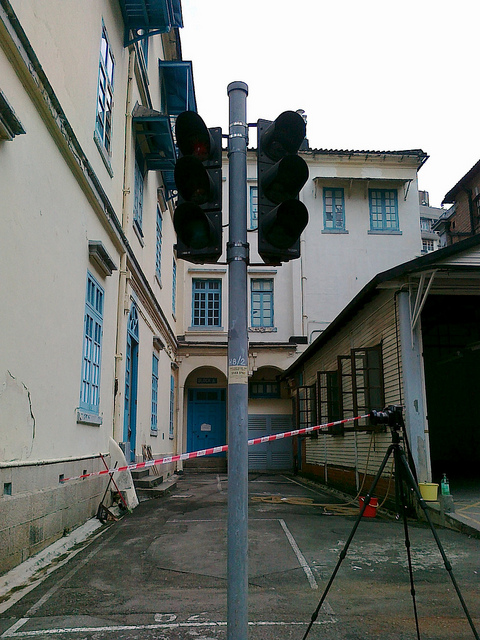<image>What color is the street light? There is no street light in the image. But it could be black or red. Does the light work? No, the light does not work. What color is the street light? There is no street light in the image. Does the light work? I don't know if the light works. It seems like it does not work. 